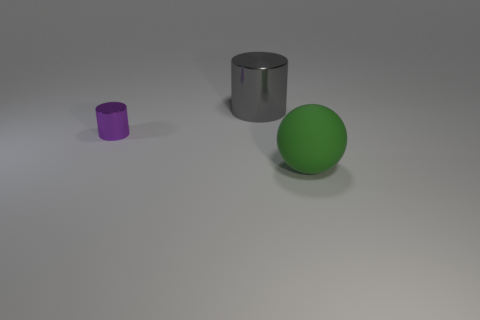Add 1 metal cylinders. How many objects exist? 4 Subtract all balls. How many objects are left? 2 Add 3 large objects. How many large objects are left? 5 Add 2 big green balls. How many big green balls exist? 3 Subtract 0 cyan cubes. How many objects are left? 3 Subtract all gray cylinders. Subtract all large shiny objects. How many objects are left? 1 